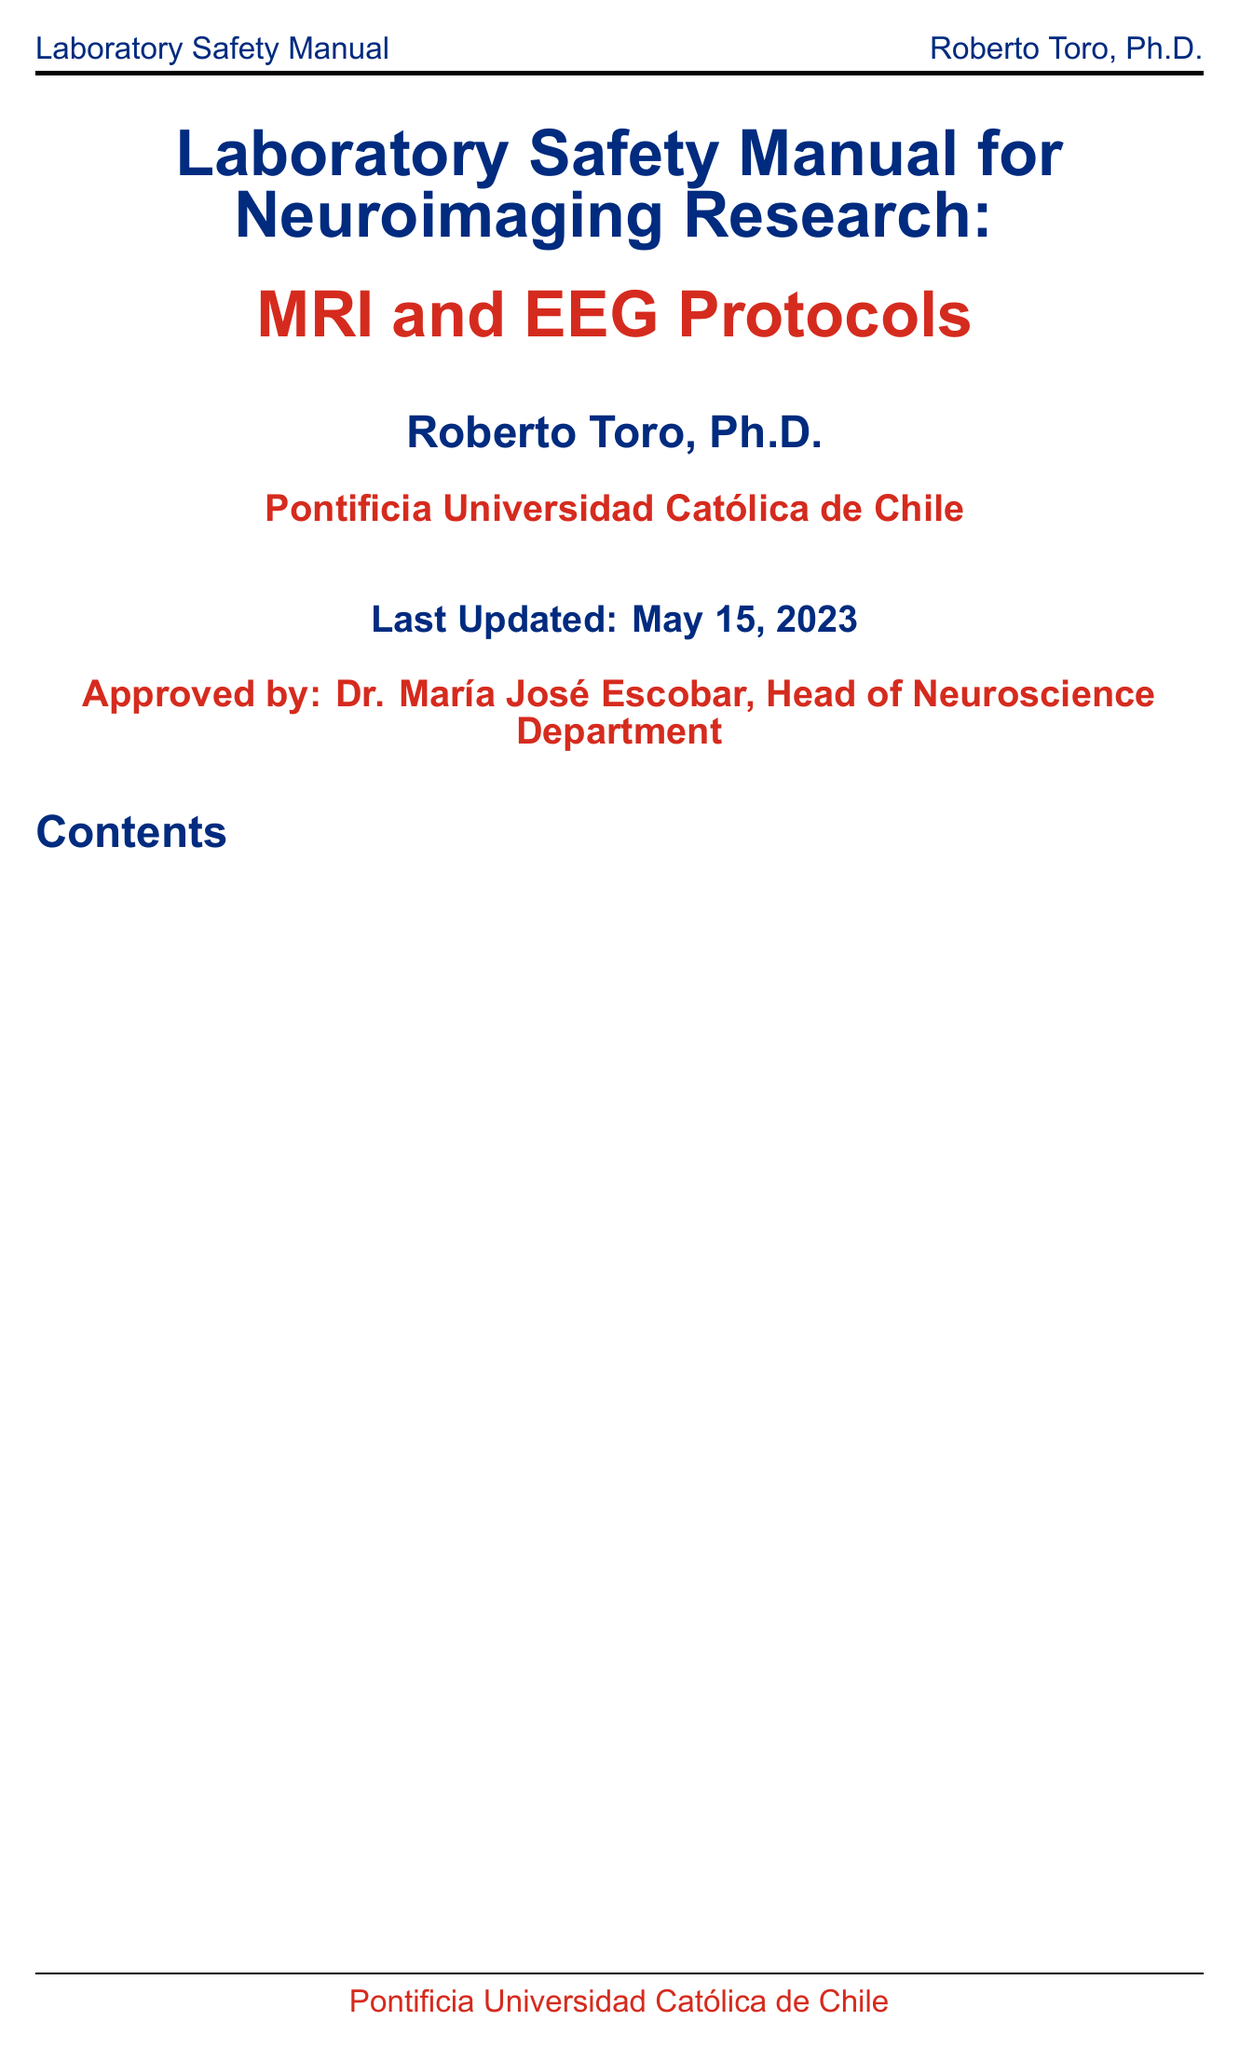what is the title of the manual? The title is stated at the beginning of the document, which provides the main topic covered.
Answer: Laboratory Safety Manual for Neuroimaging Research: MRI and EEG Protocols who is the author of the manual? The author is identified on the title page of the document, indicating who has written it.
Answer: Roberto Toro, Ph.D when was the manual last updated? The last update is mentioned at the end of the title page, indicating the currency of the information.
Answer: May 15, 2023 what is the purpose of the safety manual? The purpose is outlined in the introduction section, highlighting its importance in research.
Answer: Purpose of the safety manual how many sections are there in the manual? The number of sections can be counted in the table of contents provided in the document.
Answer: 9 what are the emergency procedures mentioned? The document lists emergency procedures in a specific section detailing protocols to follow in emergencies.
Answer: Medical emergencies during scanning what certification is required for researchers? The document specifies training and certification requirements for staff and researchers in safety protocols.
Answer: MRI safety certification process what protocols are included for EEG safety? The EEG safety protocols section provides details on safety measures for EEG practices.
Answer: Electrical safety for EEG equipment what is the compliance requirement related to data? The document mentions legal requirements concerning participant data management and privacy.
Answer: Compliance with Chilean data protection laws 